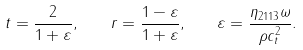<formula> <loc_0><loc_0><loc_500><loc_500>t = \frac { 2 } { 1 + \varepsilon } , \quad r = \frac { 1 - \varepsilon } { 1 + \varepsilon } , \quad \varepsilon = \frac { \eta _ { 2 1 1 3 } \omega } { \rho c _ { t } ^ { 2 } } .</formula> 